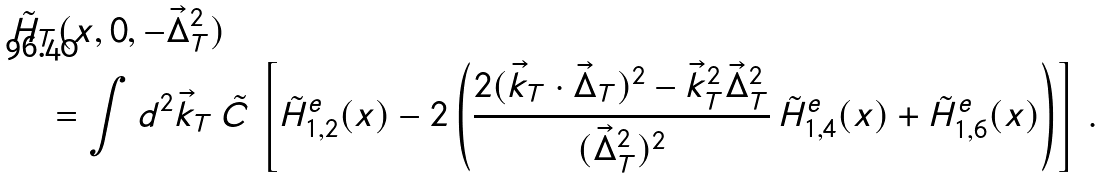Convert formula to latex. <formula><loc_0><loc_0><loc_500><loc_500>& \tilde { H } _ { T } ( x , 0 , - \vec { \Delta } _ { T } ^ { 2 } ) \\ & \quad = \int d ^ { 2 } \vec { k } _ { T } \, \tilde { C } \, \left [ \tilde { H } _ { 1 , 2 } ^ { e } ( x ) - 2 \left ( \frac { 2 ( \vec { k } _ { T } \cdot \vec { \Delta } _ { T } ) ^ { 2 } - \vec { k } _ { T } ^ { 2 } \vec { \Delta } _ { T } ^ { 2 } } { ( \vec { \Delta } _ { T } ^ { 2 } ) ^ { 2 } } \, \tilde { H } _ { 1 , 4 } ^ { e } ( x ) + \tilde { H } _ { 1 , 6 } ^ { e } ( x ) \right ) \right ] \, .</formula> 